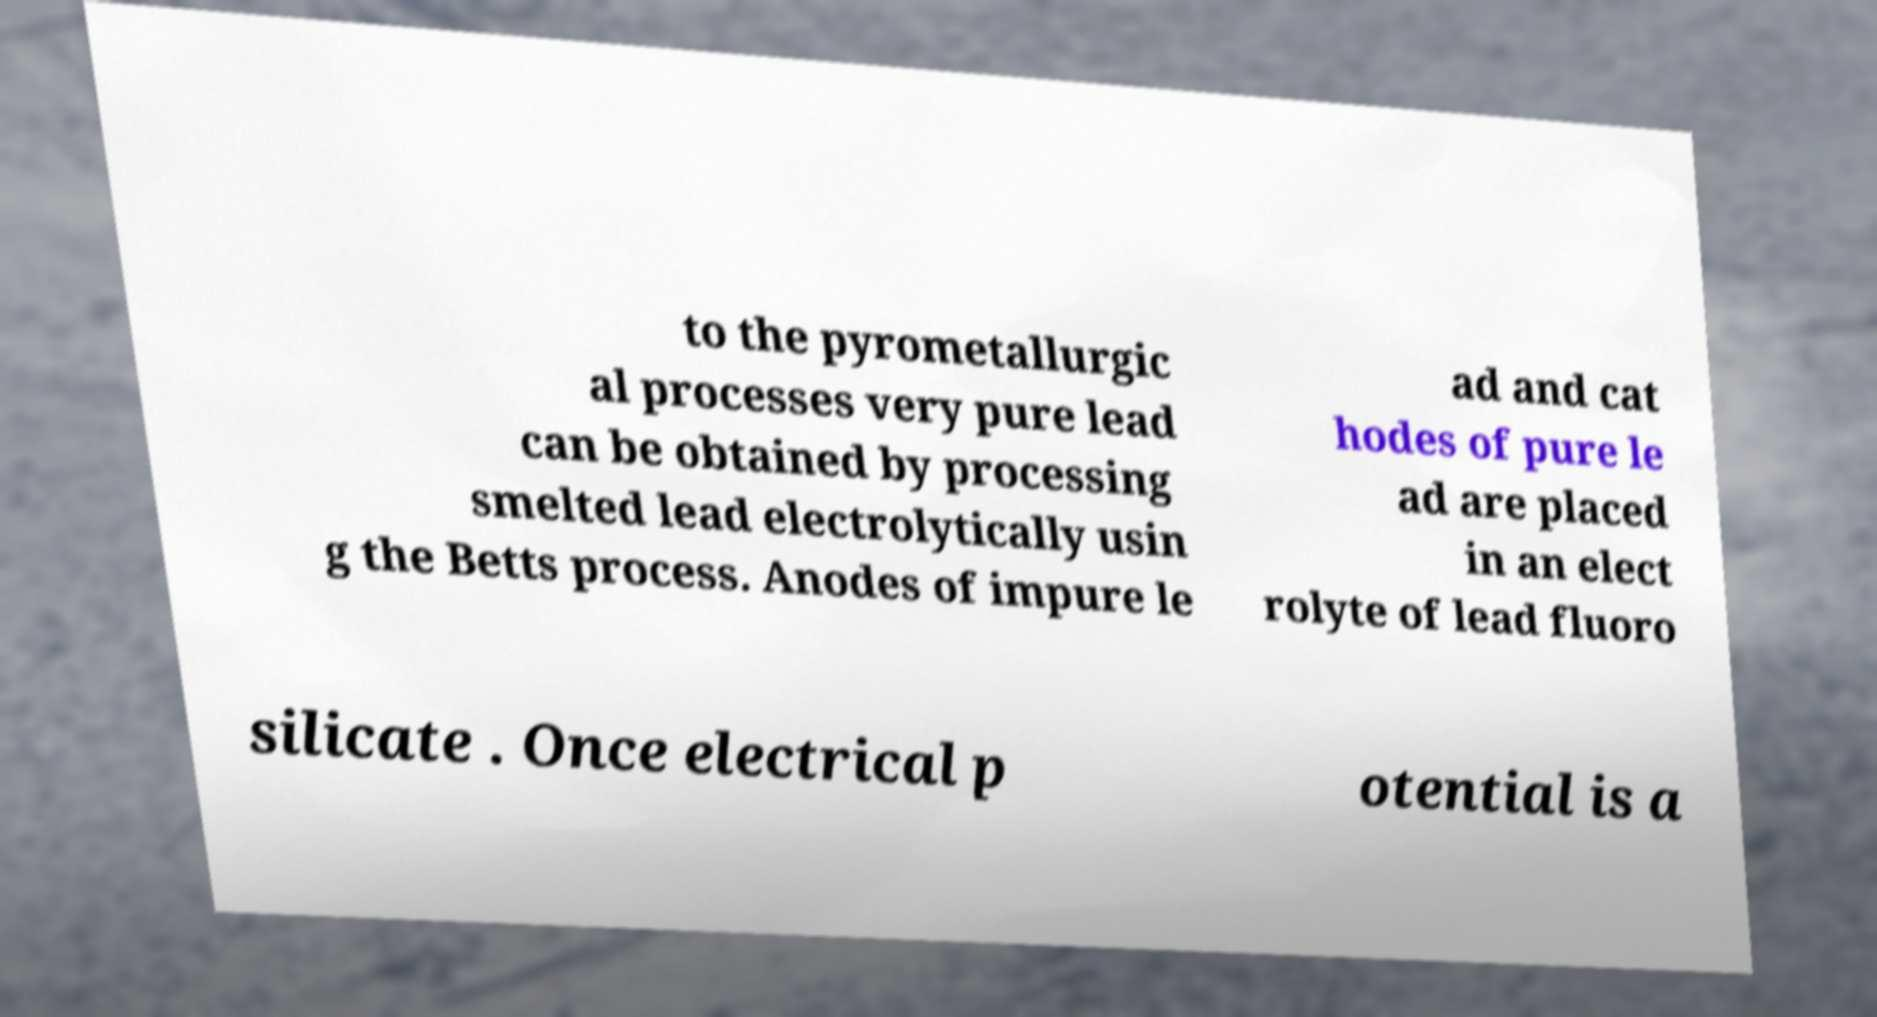Can you read and provide the text displayed in the image?This photo seems to have some interesting text. Can you extract and type it out for me? to the pyrometallurgic al processes very pure lead can be obtained by processing smelted lead electrolytically usin g the Betts process. Anodes of impure le ad and cat hodes of pure le ad are placed in an elect rolyte of lead fluoro silicate . Once electrical p otential is a 